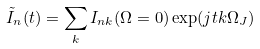<formula> <loc_0><loc_0><loc_500><loc_500>\tilde { I } _ { n } ( t ) = \sum _ { k } I _ { n k } ( \Omega = 0 ) \exp ( j t k \Omega _ { J } )</formula> 